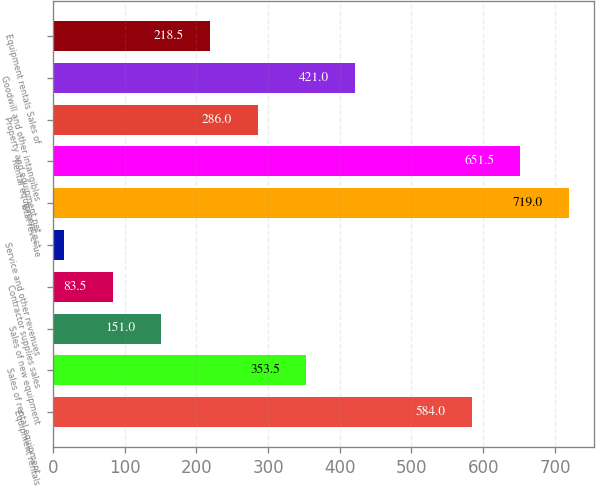Convert chart to OTSL. <chart><loc_0><loc_0><loc_500><loc_500><bar_chart><fcel>Equipment rentals<fcel>Sales of rental equipment<fcel>Sales of new equipment<fcel>Contractor supplies sales<fcel>Service and other revenues<fcel>Total revenue<fcel>Rental equipment net<fcel>Property and equipment net<fcel>Goodwill and other intangibles<fcel>Equipment rentals Sales of<nl><fcel>584<fcel>353.5<fcel>151<fcel>83.5<fcel>16<fcel>719<fcel>651.5<fcel>286<fcel>421<fcel>218.5<nl></chart> 